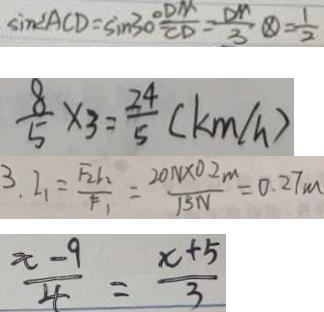Convert formula to latex. <formula><loc_0><loc_0><loc_500><loc_500>\sin \angle A C D = \sin 3 0 ^ { \circ } = \frac { D M } { C D } = \frac { D M } { 3 } \textcircled { \times } = \frac { 1 } { 2 } 
 \frac { 8 } { 5 } \times 3 = \frac { 2 4 } { 5 } ( k m / h ) 
 3 . 2 、 = \frac { F _ { 2 } r _ { 2 } } { F _ { 1 } } = \frac { 2 0 N \times 0 . 2 m } { 1 5 N } = 0 . 2 7 m 
 \frac { x - 9 } { 4 } = \frac { x + 5 } { 3 }</formula> 